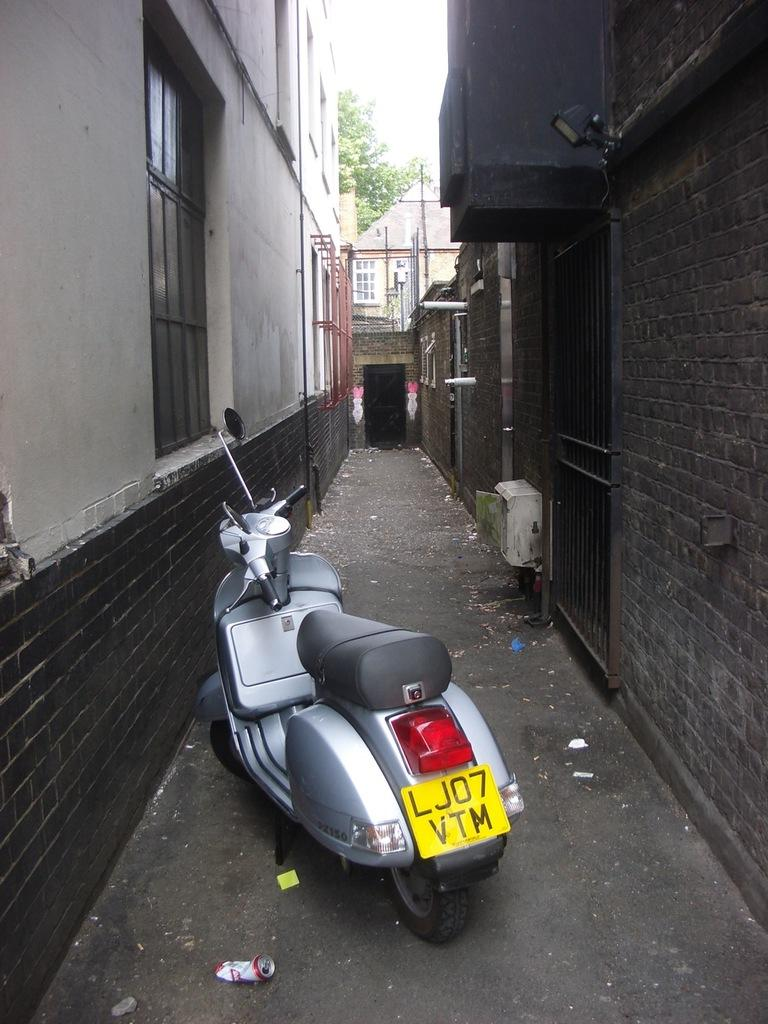What is the main subject of the image? The main subject of the image is a motorcycle. What else can be seen in the image besides the motorcycle? There are buildings, a window, a tree, and the sky visible in the image. Can you describe the buildings in the image? The buildings in the image are likely structures that are part of a city or town. What is the purpose of the window in the image? The window in the image is likely a part of a building, providing light and ventilation. What type of plantation can be seen in the image? There is no plantation present in the image. 